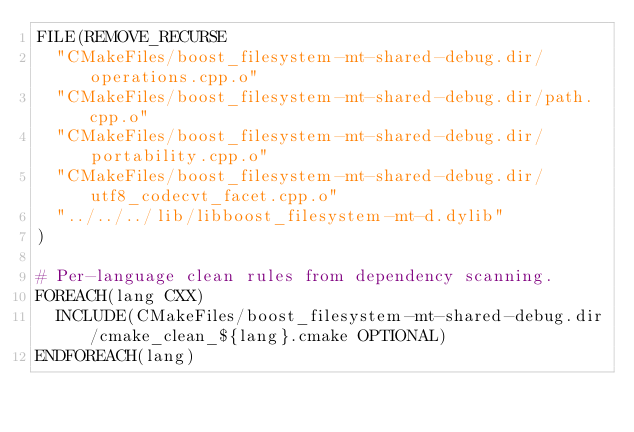<code> <loc_0><loc_0><loc_500><loc_500><_CMake_>FILE(REMOVE_RECURSE
  "CMakeFiles/boost_filesystem-mt-shared-debug.dir/operations.cpp.o"
  "CMakeFiles/boost_filesystem-mt-shared-debug.dir/path.cpp.o"
  "CMakeFiles/boost_filesystem-mt-shared-debug.dir/portability.cpp.o"
  "CMakeFiles/boost_filesystem-mt-shared-debug.dir/utf8_codecvt_facet.cpp.o"
  "../../../lib/libboost_filesystem-mt-d.dylib"
)

# Per-language clean rules from dependency scanning.
FOREACH(lang CXX)
  INCLUDE(CMakeFiles/boost_filesystem-mt-shared-debug.dir/cmake_clean_${lang}.cmake OPTIONAL)
ENDFOREACH(lang)
</code> 